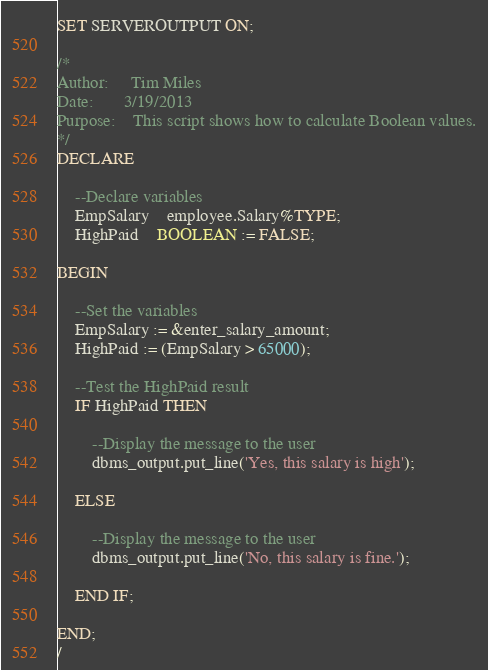Convert code to text. <code><loc_0><loc_0><loc_500><loc_500><_SQL_>SET SERVEROUTPUT ON;

/*
Author:		Tim Miles
Date:		3/19/2013
Purpose:	This script shows how to calculate Boolean values.
*/
DECLARE

	--Declare variables
	EmpSalary	employee.Salary%TYPE;
	HighPaid	BOOLEAN := FALSE;
	
BEGIN

	--Set the variables
	EmpSalary := &enter_salary_amount;
	HighPaid := (EmpSalary > 65000);
	
	--Test the HighPaid result
	IF HighPaid THEN
	
		--Display the message to the user
		dbms_output.put_line('Yes, this salary is high');

	ELSE
	
		--Display the message to the user
		dbms_output.put_line('No, this salary is fine.');

	END IF;
	
END;
/</code> 